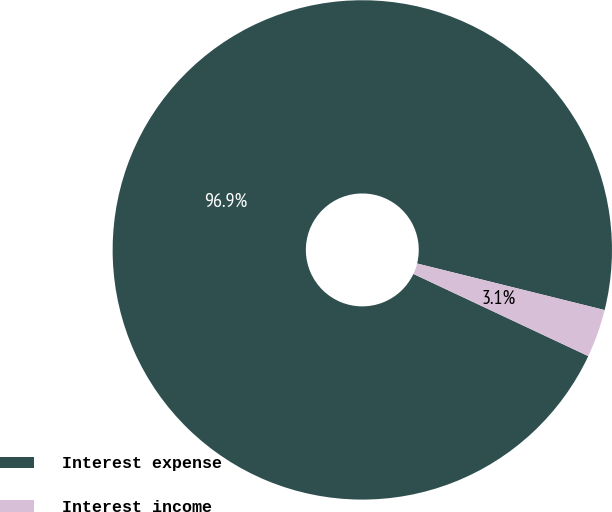Convert chart. <chart><loc_0><loc_0><loc_500><loc_500><pie_chart><fcel>Interest expense<fcel>Interest income<nl><fcel>96.88%<fcel>3.12%<nl></chart> 